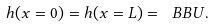<formula> <loc_0><loc_0><loc_500><loc_500>h ( x = 0 ) = h ( x = L ) = \ B B U .</formula> 